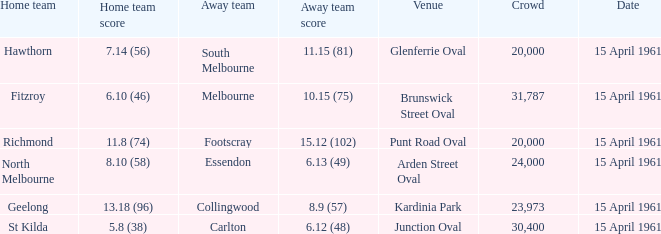In which location did the home team achieve a score of 6.10 (46)? Brunswick Street Oval. 